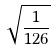Convert formula to latex. <formula><loc_0><loc_0><loc_500><loc_500>\sqrt { \frac { 1 } { 1 2 6 } }</formula> 